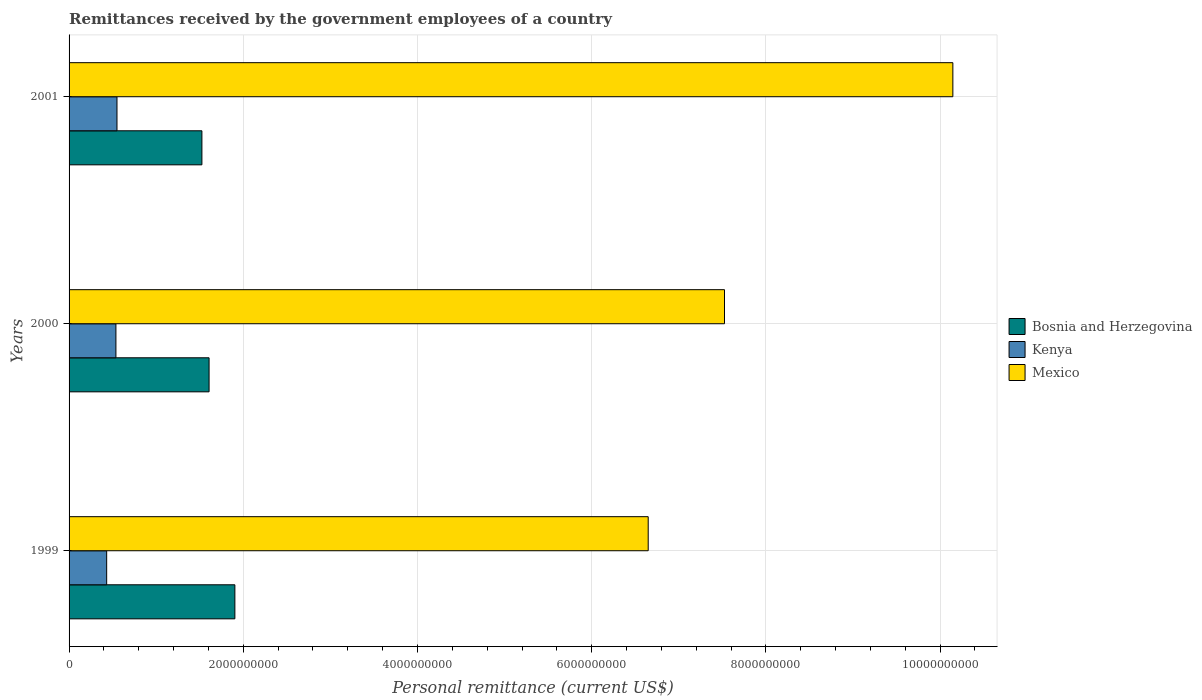How many different coloured bars are there?
Keep it short and to the point. 3. What is the label of the 2nd group of bars from the top?
Give a very brief answer. 2000. What is the remittances received by the government employees in Mexico in 2000?
Provide a succinct answer. 7.52e+09. Across all years, what is the maximum remittances received by the government employees in Mexico?
Give a very brief answer. 1.01e+1. Across all years, what is the minimum remittances received by the government employees in Mexico?
Ensure brevity in your answer.  6.65e+09. In which year was the remittances received by the government employees in Kenya maximum?
Make the answer very short. 2001. In which year was the remittances received by the government employees in Mexico minimum?
Offer a terse response. 1999. What is the total remittances received by the government employees in Bosnia and Herzegovina in the graph?
Provide a short and direct response. 5.04e+09. What is the difference between the remittances received by the government employees in Bosnia and Herzegovina in 1999 and that in 2001?
Offer a very short reply. 3.79e+08. What is the difference between the remittances received by the government employees in Kenya in 2000 and the remittances received by the government employees in Bosnia and Herzegovina in 2001?
Offer a terse response. -9.87e+08. What is the average remittances received by the government employees in Bosnia and Herzegovina per year?
Make the answer very short. 1.68e+09. In the year 2000, what is the difference between the remittances received by the government employees in Mexico and remittances received by the government employees in Kenya?
Give a very brief answer. 6.99e+09. What is the ratio of the remittances received by the government employees in Mexico in 1999 to that in 2000?
Ensure brevity in your answer.  0.88. Is the remittances received by the government employees in Bosnia and Herzegovina in 2000 less than that in 2001?
Your answer should be compact. No. Is the difference between the remittances received by the government employees in Mexico in 1999 and 2001 greater than the difference between the remittances received by the government employees in Kenya in 1999 and 2001?
Your answer should be very brief. No. What is the difference between the highest and the second highest remittances received by the government employees in Kenya?
Keep it short and to the point. 1.21e+07. What is the difference between the highest and the lowest remittances received by the government employees in Mexico?
Your answer should be compact. 3.50e+09. In how many years, is the remittances received by the government employees in Mexico greater than the average remittances received by the government employees in Mexico taken over all years?
Offer a very short reply. 1. What does the 3rd bar from the top in 2001 represents?
Your response must be concise. Bosnia and Herzegovina. What does the 3rd bar from the bottom in 2000 represents?
Give a very brief answer. Mexico. Is it the case that in every year, the sum of the remittances received by the government employees in Bosnia and Herzegovina and remittances received by the government employees in Kenya is greater than the remittances received by the government employees in Mexico?
Offer a very short reply. No. How many bars are there?
Give a very brief answer. 9. What is the difference between two consecutive major ticks on the X-axis?
Your answer should be compact. 2.00e+09. Are the values on the major ticks of X-axis written in scientific E-notation?
Offer a very short reply. No. Does the graph contain grids?
Your answer should be very brief. Yes. Where does the legend appear in the graph?
Your response must be concise. Center right. What is the title of the graph?
Give a very brief answer. Remittances received by the government employees of a country. Does "Yemen, Rep." appear as one of the legend labels in the graph?
Make the answer very short. No. What is the label or title of the X-axis?
Ensure brevity in your answer.  Personal remittance (current US$). What is the label or title of the Y-axis?
Ensure brevity in your answer.  Years. What is the Personal remittance (current US$) of Bosnia and Herzegovina in 1999?
Provide a short and direct response. 1.90e+09. What is the Personal remittance (current US$) in Kenya in 1999?
Give a very brief answer. 4.32e+08. What is the Personal remittance (current US$) in Mexico in 1999?
Keep it short and to the point. 6.65e+09. What is the Personal remittance (current US$) of Bosnia and Herzegovina in 2000?
Offer a very short reply. 1.61e+09. What is the Personal remittance (current US$) in Kenya in 2000?
Keep it short and to the point. 5.38e+08. What is the Personal remittance (current US$) in Mexico in 2000?
Provide a short and direct response. 7.52e+09. What is the Personal remittance (current US$) of Bosnia and Herzegovina in 2001?
Offer a very short reply. 1.52e+09. What is the Personal remittance (current US$) of Kenya in 2001?
Keep it short and to the point. 5.50e+08. What is the Personal remittance (current US$) in Mexico in 2001?
Provide a succinct answer. 1.01e+1. Across all years, what is the maximum Personal remittance (current US$) of Bosnia and Herzegovina?
Give a very brief answer. 1.90e+09. Across all years, what is the maximum Personal remittance (current US$) in Kenya?
Give a very brief answer. 5.50e+08. Across all years, what is the maximum Personal remittance (current US$) in Mexico?
Your response must be concise. 1.01e+1. Across all years, what is the minimum Personal remittance (current US$) in Bosnia and Herzegovina?
Offer a terse response. 1.52e+09. Across all years, what is the minimum Personal remittance (current US$) in Kenya?
Offer a terse response. 4.32e+08. Across all years, what is the minimum Personal remittance (current US$) of Mexico?
Your answer should be compact. 6.65e+09. What is the total Personal remittance (current US$) of Bosnia and Herzegovina in the graph?
Keep it short and to the point. 5.04e+09. What is the total Personal remittance (current US$) of Kenya in the graph?
Your answer should be compact. 1.52e+09. What is the total Personal remittance (current US$) of Mexico in the graph?
Keep it short and to the point. 2.43e+1. What is the difference between the Personal remittance (current US$) in Bosnia and Herzegovina in 1999 and that in 2000?
Your answer should be very brief. 2.96e+08. What is the difference between the Personal remittance (current US$) in Kenya in 1999 and that in 2000?
Your answer should be very brief. -1.06e+08. What is the difference between the Personal remittance (current US$) in Mexico in 1999 and that in 2000?
Offer a very short reply. -8.76e+08. What is the difference between the Personal remittance (current US$) in Bosnia and Herzegovina in 1999 and that in 2001?
Your response must be concise. 3.79e+08. What is the difference between the Personal remittance (current US$) in Kenya in 1999 and that in 2001?
Keep it short and to the point. -1.18e+08. What is the difference between the Personal remittance (current US$) in Mexico in 1999 and that in 2001?
Provide a short and direct response. -3.50e+09. What is the difference between the Personal remittance (current US$) of Bosnia and Herzegovina in 2000 and that in 2001?
Give a very brief answer. 8.24e+07. What is the difference between the Personal remittance (current US$) in Kenya in 2000 and that in 2001?
Ensure brevity in your answer.  -1.21e+07. What is the difference between the Personal remittance (current US$) of Mexico in 2000 and that in 2001?
Ensure brevity in your answer.  -2.62e+09. What is the difference between the Personal remittance (current US$) of Bosnia and Herzegovina in 1999 and the Personal remittance (current US$) of Kenya in 2000?
Make the answer very short. 1.37e+09. What is the difference between the Personal remittance (current US$) in Bosnia and Herzegovina in 1999 and the Personal remittance (current US$) in Mexico in 2000?
Give a very brief answer. -5.62e+09. What is the difference between the Personal remittance (current US$) of Kenya in 1999 and the Personal remittance (current US$) of Mexico in 2000?
Provide a succinct answer. -7.09e+09. What is the difference between the Personal remittance (current US$) of Bosnia and Herzegovina in 1999 and the Personal remittance (current US$) of Kenya in 2001?
Make the answer very short. 1.35e+09. What is the difference between the Personal remittance (current US$) in Bosnia and Herzegovina in 1999 and the Personal remittance (current US$) in Mexico in 2001?
Offer a terse response. -8.24e+09. What is the difference between the Personal remittance (current US$) of Kenya in 1999 and the Personal remittance (current US$) of Mexico in 2001?
Keep it short and to the point. -9.71e+09. What is the difference between the Personal remittance (current US$) of Bosnia and Herzegovina in 2000 and the Personal remittance (current US$) of Kenya in 2001?
Your answer should be very brief. 1.06e+09. What is the difference between the Personal remittance (current US$) in Bosnia and Herzegovina in 2000 and the Personal remittance (current US$) in Mexico in 2001?
Offer a very short reply. -8.54e+09. What is the difference between the Personal remittance (current US$) of Kenya in 2000 and the Personal remittance (current US$) of Mexico in 2001?
Your answer should be very brief. -9.61e+09. What is the average Personal remittance (current US$) in Bosnia and Herzegovina per year?
Your answer should be very brief. 1.68e+09. What is the average Personal remittance (current US$) in Kenya per year?
Offer a terse response. 5.07e+08. What is the average Personal remittance (current US$) in Mexico per year?
Ensure brevity in your answer.  8.11e+09. In the year 1999, what is the difference between the Personal remittance (current US$) of Bosnia and Herzegovina and Personal remittance (current US$) of Kenya?
Provide a succinct answer. 1.47e+09. In the year 1999, what is the difference between the Personal remittance (current US$) in Bosnia and Herzegovina and Personal remittance (current US$) in Mexico?
Make the answer very short. -4.75e+09. In the year 1999, what is the difference between the Personal remittance (current US$) of Kenya and Personal remittance (current US$) of Mexico?
Your response must be concise. -6.22e+09. In the year 2000, what is the difference between the Personal remittance (current US$) in Bosnia and Herzegovina and Personal remittance (current US$) in Kenya?
Offer a very short reply. 1.07e+09. In the year 2000, what is the difference between the Personal remittance (current US$) of Bosnia and Herzegovina and Personal remittance (current US$) of Mexico?
Offer a very short reply. -5.92e+09. In the year 2000, what is the difference between the Personal remittance (current US$) of Kenya and Personal remittance (current US$) of Mexico?
Your response must be concise. -6.99e+09. In the year 2001, what is the difference between the Personal remittance (current US$) in Bosnia and Herzegovina and Personal remittance (current US$) in Kenya?
Offer a very short reply. 9.75e+08. In the year 2001, what is the difference between the Personal remittance (current US$) in Bosnia and Herzegovina and Personal remittance (current US$) in Mexico?
Provide a short and direct response. -8.62e+09. In the year 2001, what is the difference between the Personal remittance (current US$) of Kenya and Personal remittance (current US$) of Mexico?
Provide a short and direct response. -9.60e+09. What is the ratio of the Personal remittance (current US$) in Bosnia and Herzegovina in 1999 to that in 2000?
Your answer should be very brief. 1.18. What is the ratio of the Personal remittance (current US$) in Kenya in 1999 to that in 2000?
Your answer should be very brief. 0.8. What is the ratio of the Personal remittance (current US$) of Mexico in 1999 to that in 2000?
Give a very brief answer. 0.88. What is the ratio of the Personal remittance (current US$) in Bosnia and Herzegovina in 1999 to that in 2001?
Your response must be concise. 1.25. What is the ratio of the Personal remittance (current US$) in Kenya in 1999 to that in 2001?
Provide a succinct answer. 0.78. What is the ratio of the Personal remittance (current US$) of Mexico in 1999 to that in 2001?
Ensure brevity in your answer.  0.66. What is the ratio of the Personal remittance (current US$) in Bosnia and Herzegovina in 2000 to that in 2001?
Ensure brevity in your answer.  1.05. What is the ratio of the Personal remittance (current US$) in Mexico in 2000 to that in 2001?
Provide a succinct answer. 0.74. What is the difference between the highest and the second highest Personal remittance (current US$) of Bosnia and Herzegovina?
Offer a very short reply. 2.96e+08. What is the difference between the highest and the second highest Personal remittance (current US$) of Kenya?
Provide a short and direct response. 1.21e+07. What is the difference between the highest and the second highest Personal remittance (current US$) in Mexico?
Your response must be concise. 2.62e+09. What is the difference between the highest and the lowest Personal remittance (current US$) in Bosnia and Herzegovina?
Ensure brevity in your answer.  3.79e+08. What is the difference between the highest and the lowest Personal remittance (current US$) of Kenya?
Your answer should be very brief. 1.18e+08. What is the difference between the highest and the lowest Personal remittance (current US$) of Mexico?
Your response must be concise. 3.50e+09. 